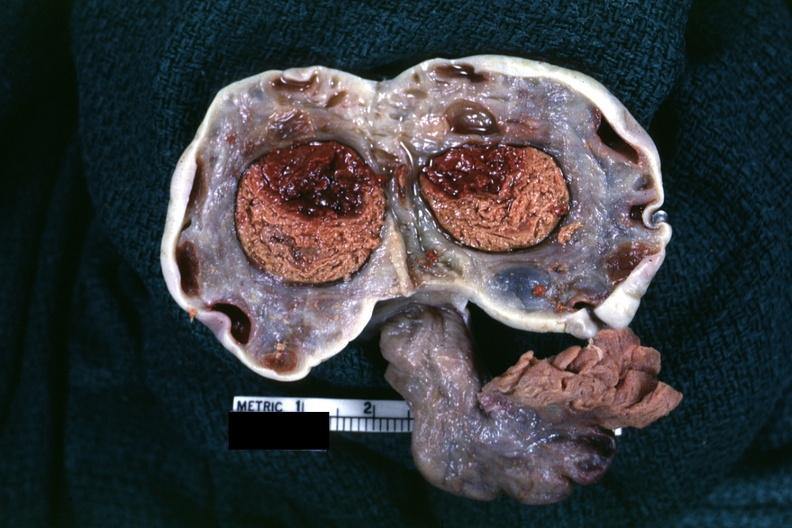s cyst present?
Answer the question using a single word or phrase. Yes 